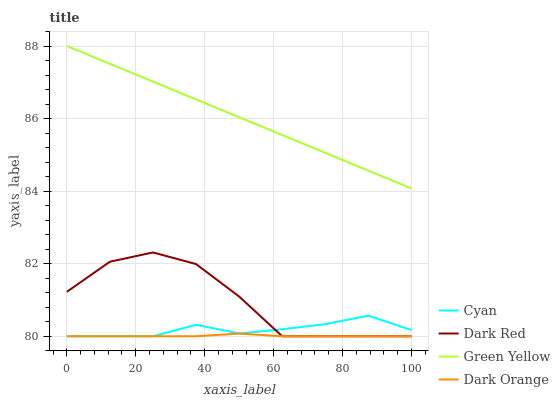Does Dark Orange have the minimum area under the curve?
Answer yes or no. Yes. Does Green Yellow have the maximum area under the curve?
Answer yes or no. Yes. Does Cyan have the minimum area under the curve?
Answer yes or no. No. Does Cyan have the maximum area under the curve?
Answer yes or no. No. Is Green Yellow the smoothest?
Answer yes or no. Yes. Is Dark Red the roughest?
Answer yes or no. Yes. Is Cyan the smoothest?
Answer yes or no. No. Is Cyan the roughest?
Answer yes or no. No. Does Dark Orange have the lowest value?
Answer yes or no. Yes. Does Green Yellow have the lowest value?
Answer yes or no. No. Does Green Yellow have the highest value?
Answer yes or no. Yes. Does Cyan have the highest value?
Answer yes or no. No. Is Cyan less than Green Yellow?
Answer yes or no. Yes. Is Green Yellow greater than Cyan?
Answer yes or no. Yes. Does Dark Red intersect Dark Orange?
Answer yes or no. Yes. Is Dark Red less than Dark Orange?
Answer yes or no. No. Is Dark Red greater than Dark Orange?
Answer yes or no. No. Does Cyan intersect Green Yellow?
Answer yes or no. No. 